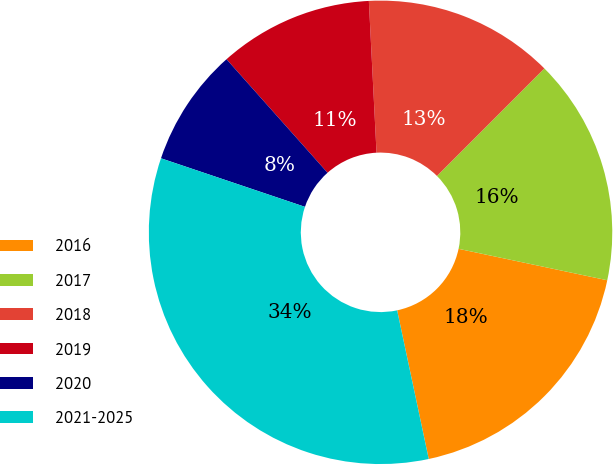Convert chart to OTSL. <chart><loc_0><loc_0><loc_500><loc_500><pie_chart><fcel>2016<fcel>2017<fcel>2018<fcel>2019<fcel>2020<fcel>2021-2025<nl><fcel>18.35%<fcel>15.82%<fcel>13.3%<fcel>10.77%<fcel>8.25%<fcel>33.51%<nl></chart> 